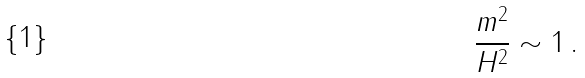Convert formula to latex. <formula><loc_0><loc_0><loc_500><loc_500>\frac { m ^ { 2 } } { H ^ { 2 } } \sim 1 \, .</formula> 